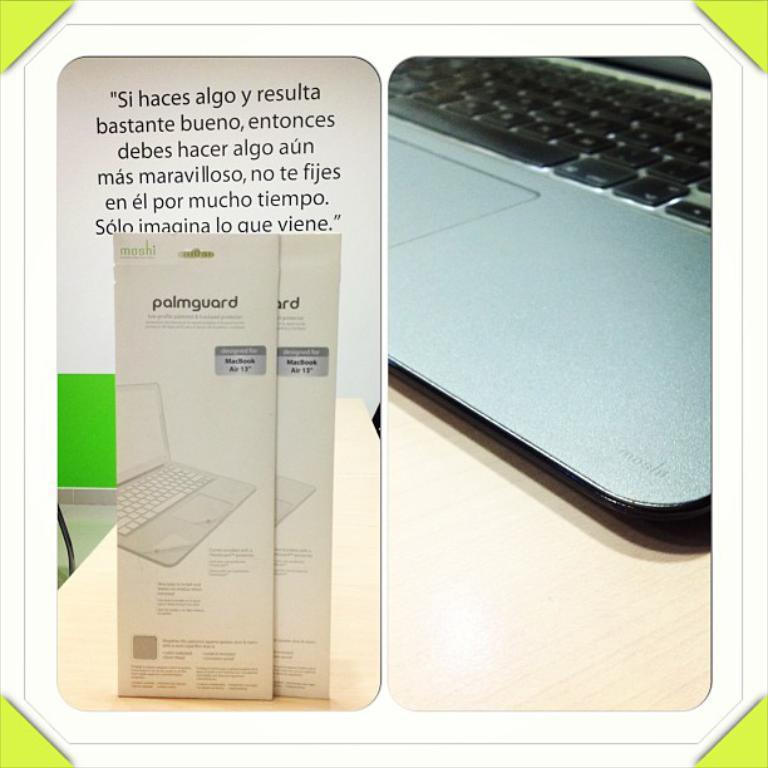<image>
Present a compact description of the photo's key features. Brochures for palmguard are nest to the image of a laptop keyboard. 